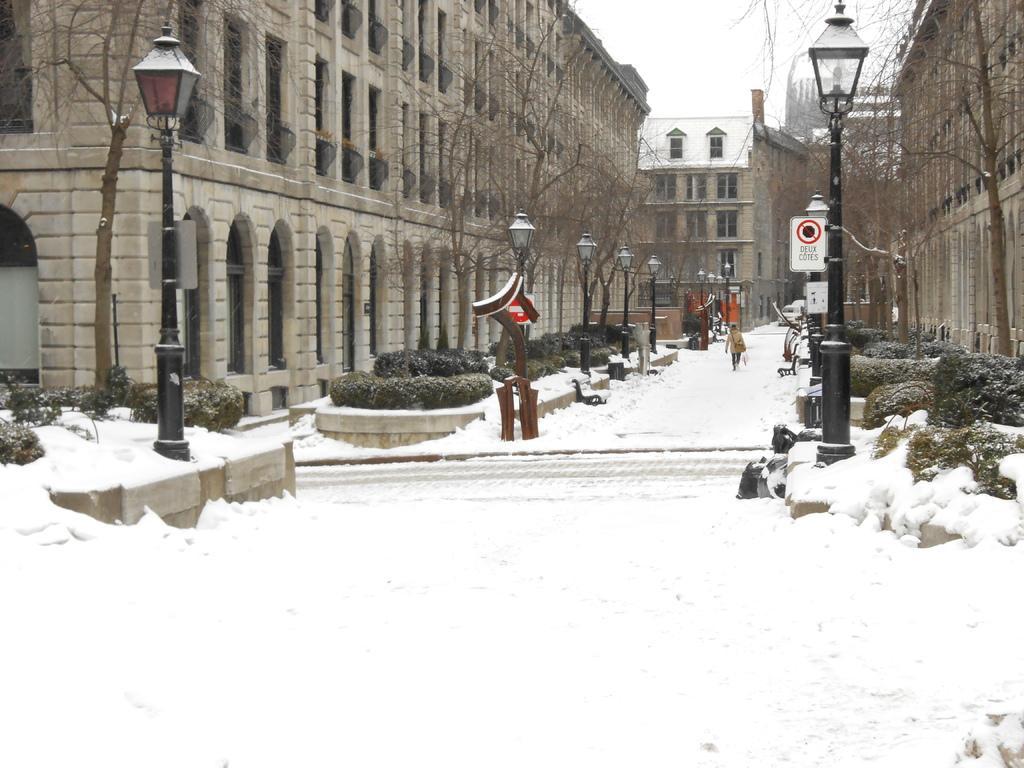Describe this image in one or two sentences. In this image we can see a group of buildings, tree poles, group of lights and in the background, we can see a person standing in the snow and the sky. 